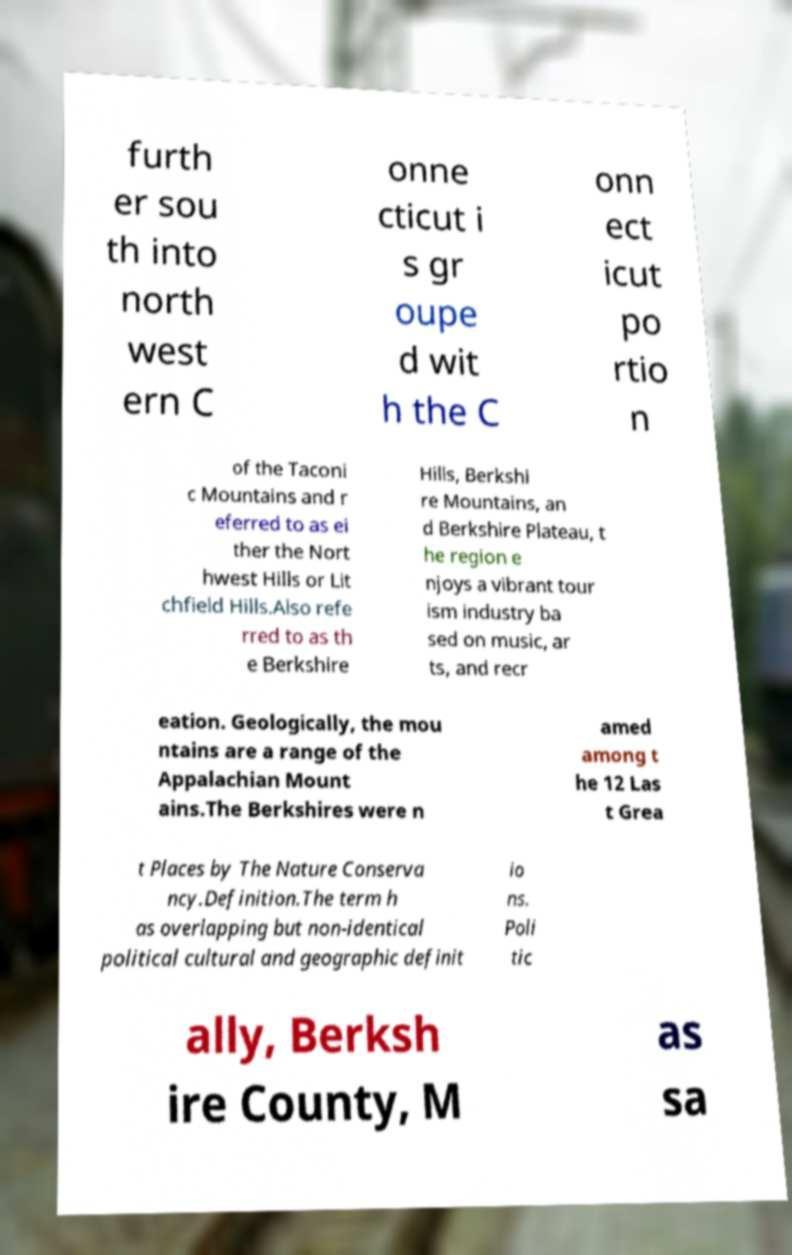I need the written content from this picture converted into text. Can you do that? furth er sou th into north west ern C onne cticut i s gr oupe d wit h the C onn ect icut po rtio n of the Taconi c Mountains and r eferred to as ei ther the Nort hwest Hills or Lit chfield Hills.Also refe rred to as th e Berkshire Hills, Berkshi re Mountains, an d Berkshire Plateau, t he region e njoys a vibrant tour ism industry ba sed on music, ar ts, and recr eation. Geologically, the mou ntains are a range of the Appalachian Mount ains.The Berkshires were n amed among t he 12 Las t Grea t Places by The Nature Conserva ncy.Definition.The term h as overlapping but non-identical political cultural and geographic definit io ns. Poli tic ally, Berksh ire County, M as sa 